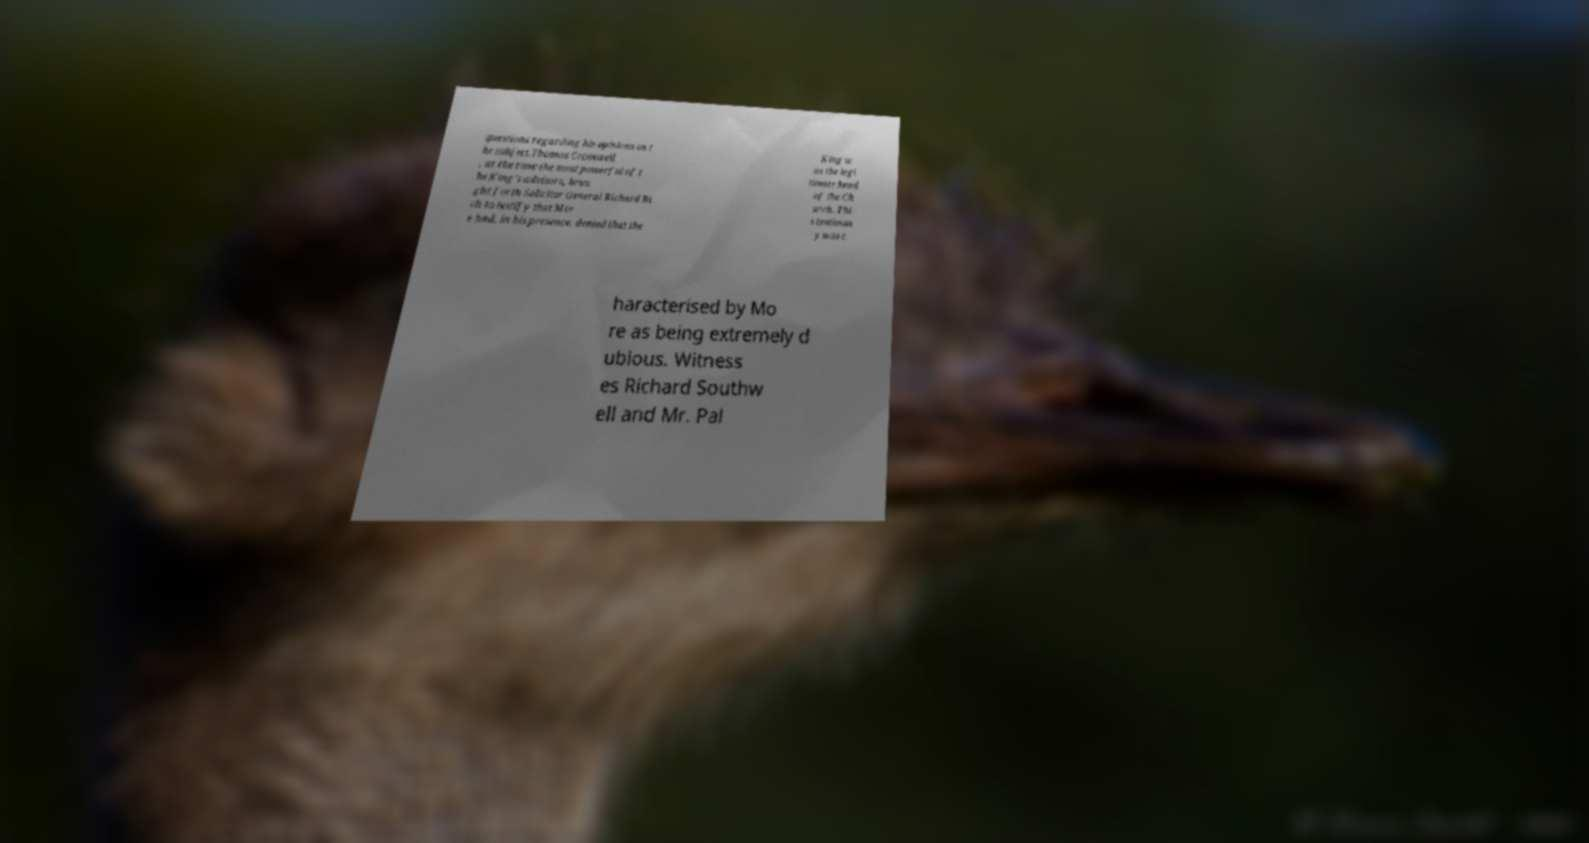Please identify and transcribe the text found in this image. questions regarding his opinions on t he subject.Thomas Cromwell , at the time the most powerful of t he King's advisors, brou ght forth Solicitor General Richard Ri ch to testify that Mor e had, in his presence, denied that the King w as the legi timate head of the Ch urch. Thi s testimon y was c haracterised by Mo re as being extremely d ubious. Witness es Richard Southw ell and Mr. Pal 